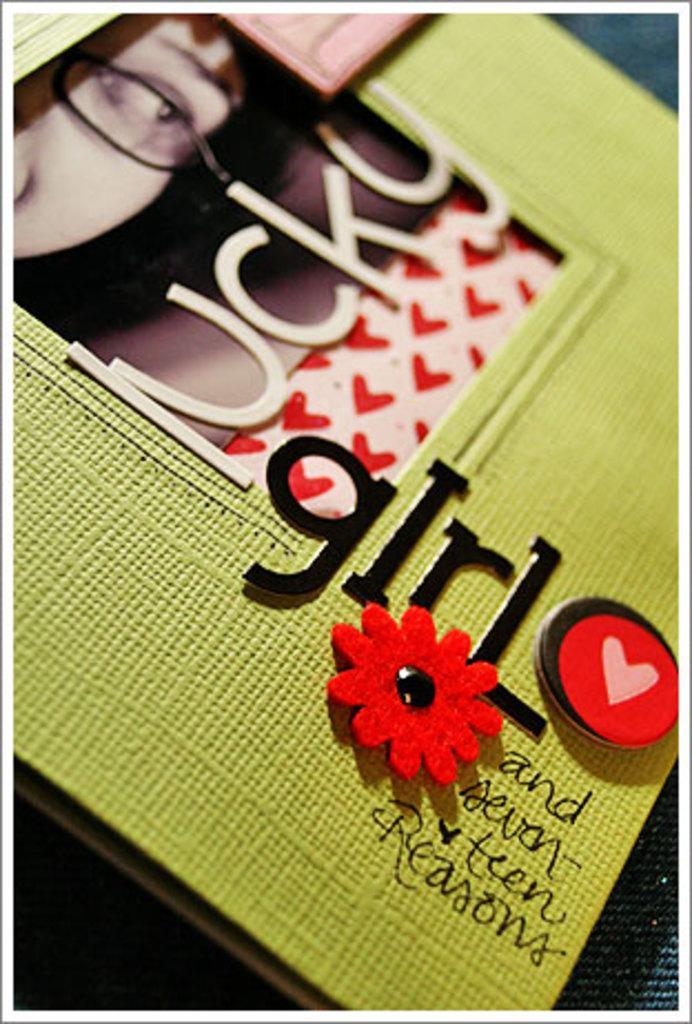Describe this image in one or two sentences. Here we can see a greeting card with text written on it on a platform and in the middle of the greeting card there is a photograph. 